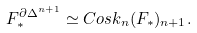<formula> <loc_0><loc_0><loc_500><loc_500>F _ { * } ^ { \partial \Delta ^ { n + 1 } } \simeq C o s k _ { n } ( F _ { * } ) _ { n + 1 } .</formula> 